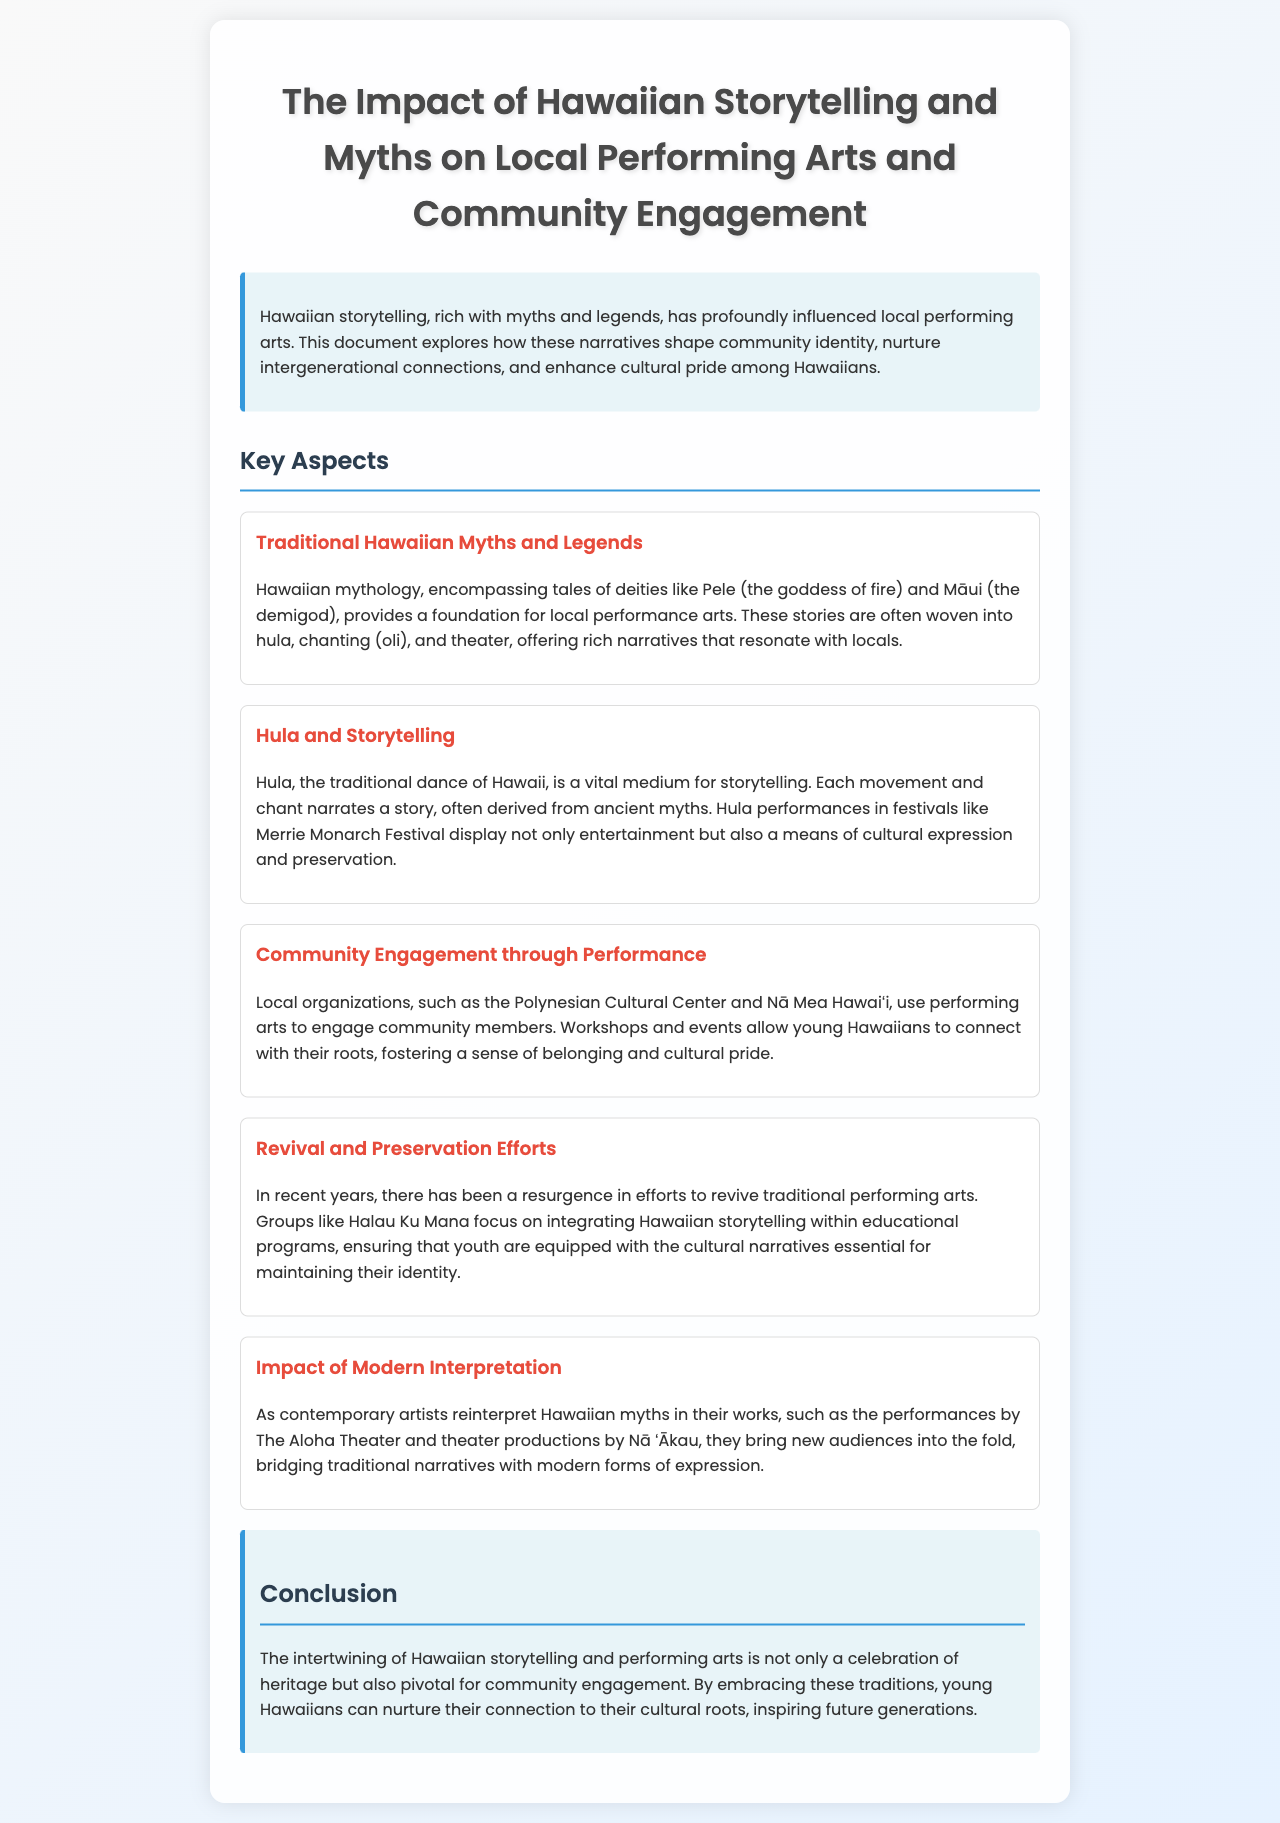What is the title of the document? The title can be found prominently at the top of the document.
Answer: The Impact of Hawaiian Storytelling and Myths on Local Performing Arts and Community Engagement Who are two deities mentioned in the document? The document lists specific deities in the section about traditional Hawaiian myths.
Answer: Pele and Māui What cultural event is highlighted for hula performances? The document mentions a specific festival where hula is showcased.
Answer: Merrie Monarch Festival Which organization is focused on integrating Hawaiian storytelling in education? The document names a group dedicated to this effort in the revival and preservation section.
Answer: Halau Ku Mana What type of dance is central to Hawaiian storytelling? The document refers to a specific dance form that communicates stories through movement.
Answer: Hula How do local organizations engage community members? The document explains activities that foster connection and cultural pride among locals.
Answer: Workshops and events What is a recent trend in Hawaiian performing arts mentioned? The document discusses a movement relating to the interpretation of traditional narratives.
Answer: Revival and Preservation Efforts What is the main benefit of intertwining storytelling and performing arts, according to the conclusion? The conclusion summarizes the impact of these traditions on community and identity.
Answer: Community engagement 